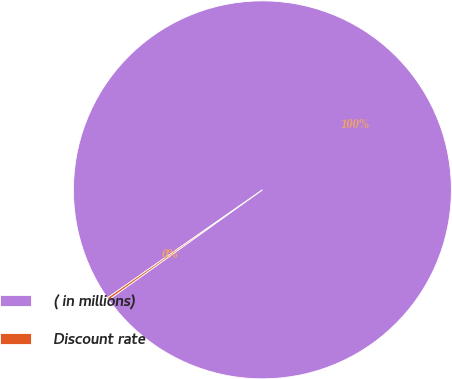Convert chart. <chart><loc_0><loc_0><loc_500><loc_500><pie_chart><fcel>( in millions)<fcel>Discount rate<nl><fcel>99.8%<fcel>0.2%<nl></chart> 